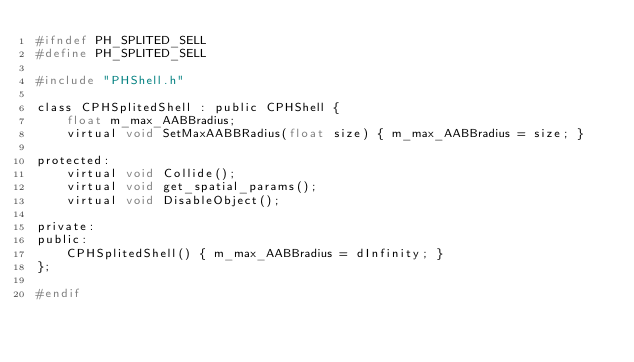<code> <loc_0><loc_0><loc_500><loc_500><_C_>#ifndef PH_SPLITED_SELL
#define PH_SPLITED_SELL

#include "PHShell.h"

class CPHSplitedShell : public CPHShell {
    float m_max_AABBradius;
    virtual void SetMaxAABBRadius(float size) { m_max_AABBradius = size; }

protected:
    virtual void Collide();
    virtual void get_spatial_params();
    virtual void DisableObject();

private:
public:
    CPHSplitedShell() { m_max_AABBradius = dInfinity; }
};

#endif</code> 